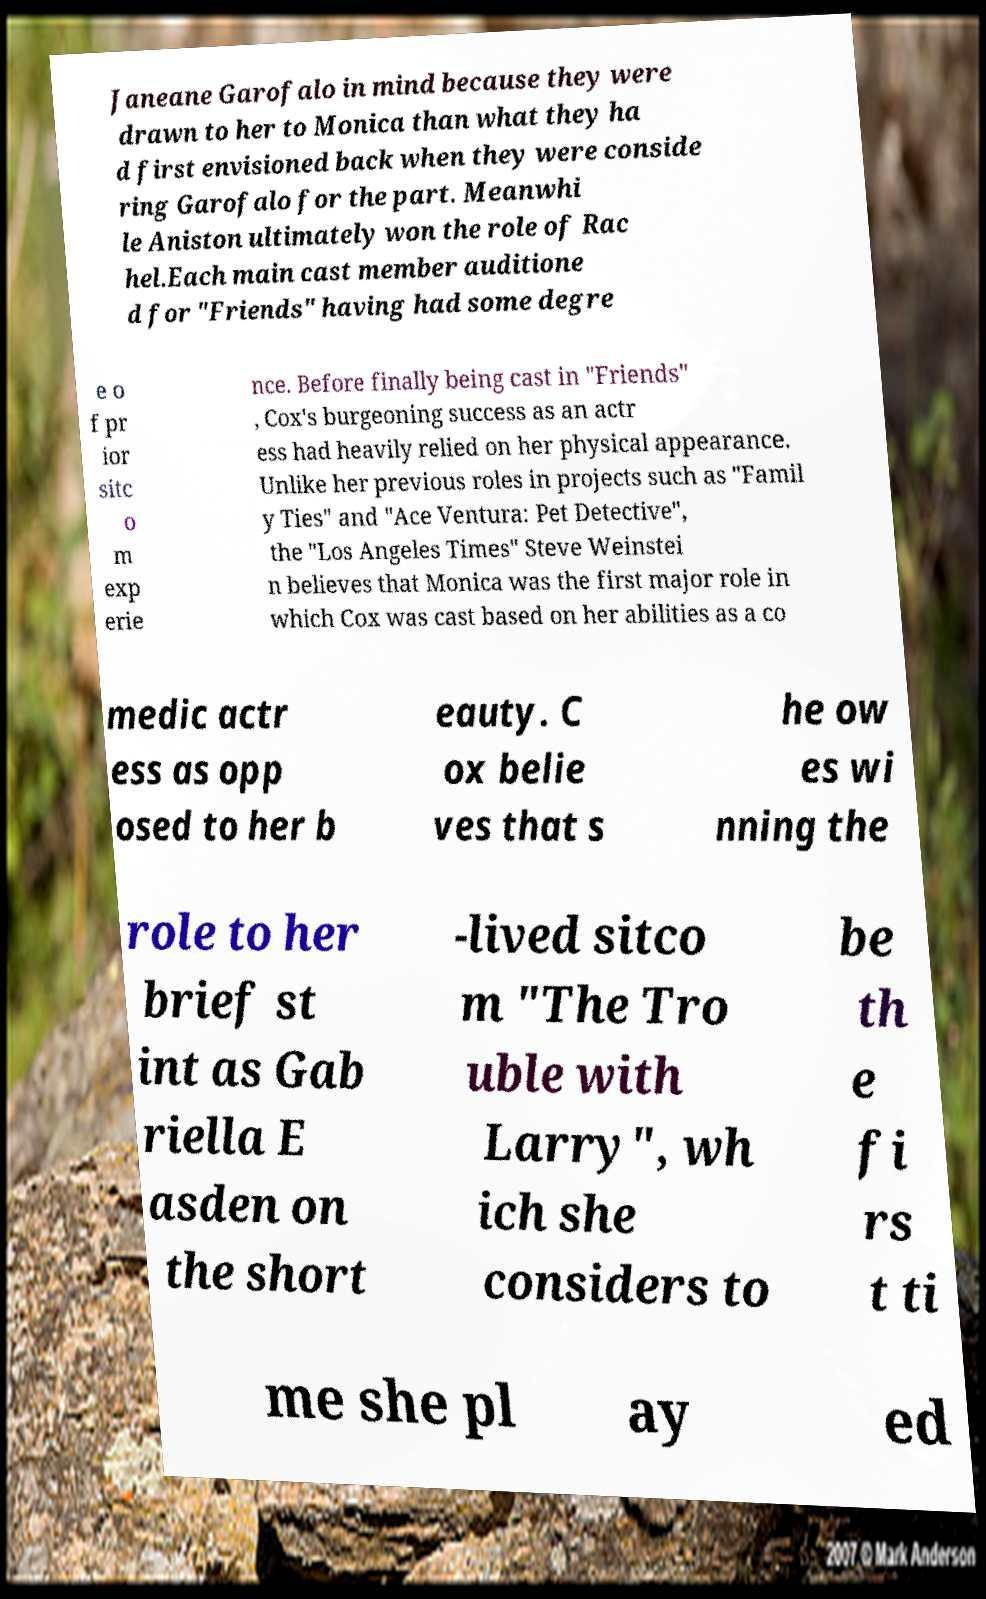What messages or text are displayed in this image? I need them in a readable, typed format. Janeane Garofalo in mind because they were drawn to her to Monica than what they ha d first envisioned back when they were conside ring Garofalo for the part. Meanwhi le Aniston ultimately won the role of Rac hel.Each main cast member auditione d for "Friends" having had some degre e o f pr ior sitc o m exp erie nce. Before finally being cast in "Friends" , Cox's burgeoning success as an actr ess had heavily relied on her physical appearance. Unlike her previous roles in projects such as "Famil y Ties" and "Ace Ventura: Pet Detective", the "Los Angeles Times" Steve Weinstei n believes that Monica was the first major role in which Cox was cast based on her abilities as a co medic actr ess as opp osed to her b eauty. C ox belie ves that s he ow es wi nning the role to her brief st int as Gab riella E asden on the short -lived sitco m "The Tro uble with Larry", wh ich she considers to be th e fi rs t ti me she pl ay ed 